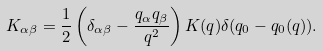Convert formula to latex. <formula><loc_0><loc_0><loc_500><loc_500>K _ { \alpha \beta } = \frac { 1 } { 2 } \left ( { \delta } _ { \alpha \beta } - \frac { q _ { \alpha } q _ { \beta } } { q ^ { 2 } } \right ) K ( q ) \delta ( q _ { 0 } - q _ { 0 } ( q ) ) .</formula> 